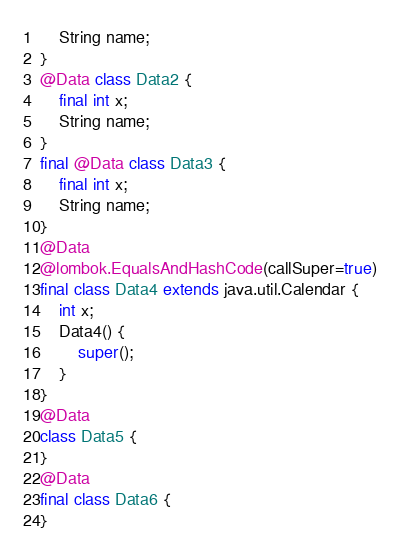<code> <loc_0><loc_0><loc_500><loc_500><_Java_>	String name;
}
@Data class Data2 {
	final int x;
	String name;
}
final @Data class Data3 {
	final int x;
	String name;
}
@Data 
@lombok.EqualsAndHashCode(callSuper=true)
final class Data4 extends java.util.Calendar {
	int x;
	Data4() {
		super();
	}
}
@Data
class Data5 {
}
@Data
final class Data6 {
}
</code> 